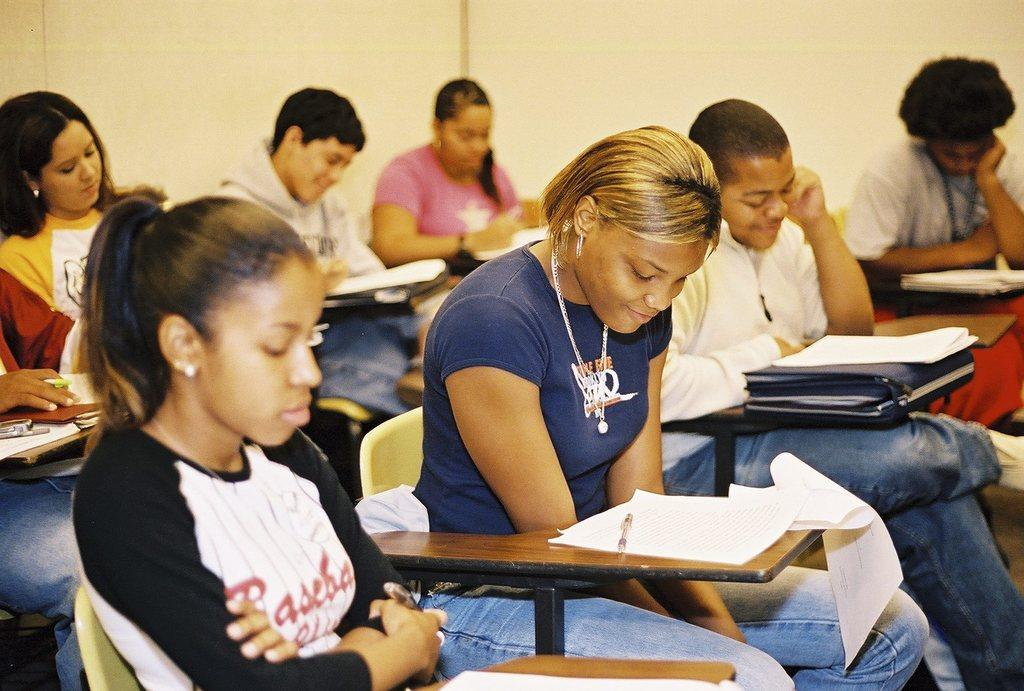What are the people in the image doing? The people in the image are seated on chairs. What objects can be seen on the table in the image? There are papers and books in the image. How are the books arranged on the table? The books are on pads in the image. What is visible on the right side of the image? There is a wall on the right side of the image. Can you see any cakes on the table in the image? No, there are no cakes present in the image. What type of cork is used to hold the books together? There is no cork present in the image; the books are on pads. 